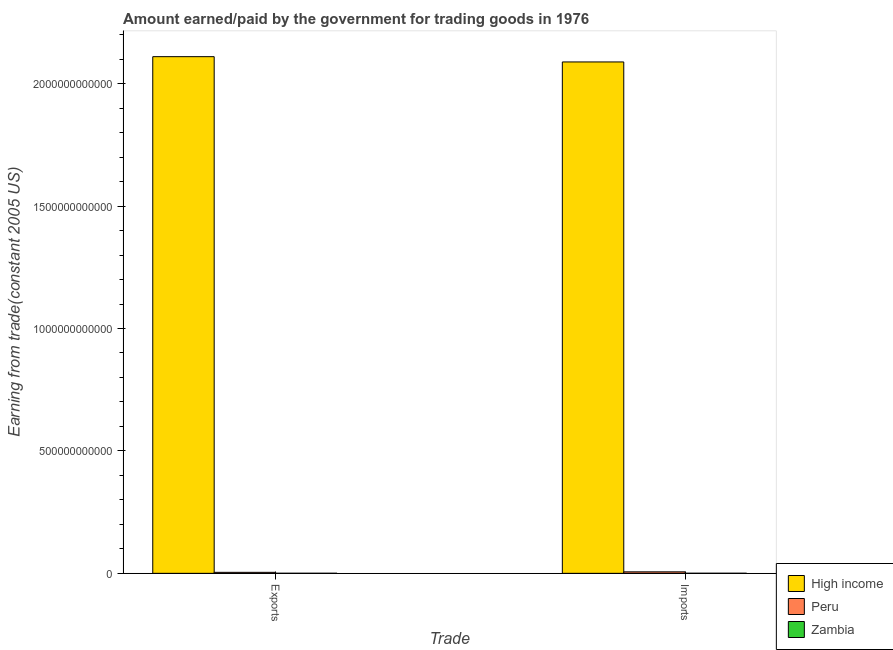How many different coloured bars are there?
Keep it short and to the point. 3. How many groups of bars are there?
Your answer should be compact. 2. How many bars are there on the 1st tick from the right?
Your answer should be compact. 3. What is the label of the 1st group of bars from the left?
Ensure brevity in your answer.  Exports. What is the amount paid for imports in Peru?
Give a very brief answer. 6.07e+09. Across all countries, what is the maximum amount paid for imports?
Provide a short and direct response. 2.09e+12. Across all countries, what is the minimum amount earned from exports?
Give a very brief answer. 3.03e+08. In which country was the amount earned from exports minimum?
Give a very brief answer. Zambia. What is the total amount earned from exports in the graph?
Offer a very short reply. 2.11e+12. What is the difference between the amount paid for imports in High income and that in Zambia?
Give a very brief answer. 2.09e+12. What is the difference between the amount earned from exports in High income and the amount paid for imports in Peru?
Offer a terse response. 2.10e+12. What is the average amount paid for imports per country?
Offer a terse response. 6.98e+11. What is the difference between the amount paid for imports and amount earned from exports in Peru?
Provide a short and direct response. 1.97e+09. What is the ratio of the amount earned from exports in Zambia to that in Peru?
Your answer should be very brief. 0.07. Is the amount earned from exports in Peru less than that in High income?
Keep it short and to the point. Yes. What does the 3rd bar from the right in Imports represents?
Offer a terse response. High income. How many bars are there?
Provide a short and direct response. 6. How many countries are there in the graph?
Make the answer very short. 3. What is the difference between two consecutive major ticks on the Y-axis?
Ensure brevity in your answer.  5.00e+11. Does the graph contain any zero values?
Your response must be concise. No. Does the graph contain grids?
Ensure brevity in your answer.  No. Where does the legend appear in the graph?
Ensure brevity in your answer.  Bottom right. What is the title of the graph?
Your response must be concise. Amount earned/paid by the government for trading goods in 1976. What is the label or title of the X-axis?
Keep it short and to the point. Trade. What is the label or title of the Y-axis?
Make the answer very short. Earning from trade(constant 2005 US). What is the Earning from trade(constant 2005 US) of High income in Exports?
Ensure brevity in your answer.  2.11e+12. What is the Earning from trade(constant 2005 US) in Peru in Exports?
Keep it short and to the point. 4.10e+09. What is the Earning from trade(constant 2005 US) in Zambia in Exports?
Keep it short and to the point. 3.03e+08. What is the Earning from trade(constant 2005 US) of High income in Imports?
Your answer should be compact. 2.09e+12. What is the Earning from trade(constant 2005 US) in Peru in Imports?
Your answer should be compact. 6.07e+09. What is the Earning from trade(constant 2005 US) of Zambia in Imports?
Your answer should be compact. 3.89e+08. Across all Trade, what is the maximum Earning from trade(constant 2005 US) in High income?
Your response must be concise. 2.11e+12. Across all Trade, what is the maximum Earning from trade(constant 2005 US) of Peru?
Make the answer very short. 6.07e+09. Across all Trade, what is the maximum Earning from trade(constant 2005 US) of Zambia?
Offer a very short reply. 3.89e+08. Across all Trade, what is the minimum Earning from trade(constant 2005 US) of High income?
Ensure brevity in your answer.  2.09e+12. Across all Trade, what is the minimum Earning from trade(constant 2005 US) in Peru?
Keep it short and to the point. 4.10e+09. Across all Trade, what is the minimum Earning from trade(constant 2005 US) of Zambia?
Make the answer very short. 3.03e+08. What is the total Earning from trade(constant 2005 US) of High income in the graph?
Offer a terse response. 4.20e+12. What is the total Earning from trade(constant 2005 US) of Peru in the graph?
Provide a short and direct response. 1.02e+1. What is the total Earning from trade(constant 2005 US) of Zambia in the graph?
Provide a short and direct response. 6.92e+08. What is the difference between the Earning from trade(constant 2005 US) of High income in Exports and that in Imports?
Keep it short and to the point. 2.16e+1. What is the difference between the Earning from trade(constant 2005 US) of Peru in Exports and that in Imports?
Your response must be concise. -1.97e+09. What is the difference between the Earning from trade(constant 2005 US) in Zambia in Exports and that in Imports?
Give a very brief answer. -8.56e+07. What is the difference between the Earning from trade(constant 2005 US) in High income in Exports and the Earning from trade(constant 2005 US) in Peru in Imports?
Keep it short and to the point. 2.10e+12. What is the difference between the Earning from trade(constant 2005 US) in High income in Exports and the Earning from trade(constant 2005 US) in Zambia in Imports?
Provide a succinct answer. 2.11e+12. What is the difference between the Earning from trade(constant 2005 US) in Peru in Exports and the Earning from trade(constant 2005 US) in Zambia in Imports?
Your answer should be compact. 3.71e+09. What is the average Earning from trade(constant 2005 US) in High income per Trade?
Offer a very short reply. 2.10e+12. What is the average Earning from trade(constant 2005 US) of Peru per Trade?
Keep it short and to the point. 5.08e+09. What is the average Earning from trade(constant 2005 US) in Zambia per Trade?
Ensure brevity in your answer.  3.46e+08. What is the difference between the Earning from trade(constant 2005 US) in High income and Earning from trade(constant 2005 US) in Peru in Exports?
Give a very brief answer. 2.11e+12. What is the difference between the Earning from trade(constant 2005 US) in High income and Earning from trade(constant 2005 US) in Zambia in Exports?
Offer a very short reply. 2.11e+12. What is the difference between the Earning from trade(constant 2005 US) in Peru and Earning from trade(constant 2005 US) in Zambia in Exports?
Your answer should be compact. 3.79e+09. What is the difference between the Earning from trade(constant 2005 US) in High income and Earning from trade(constant 2005 US) in Peru in Imports?
Provide a short and direct response. 2.08e+12. What is the difference between the Earning from trade(constant 2005 US) of High income and Earning from trade(constant 2005 US) of Zambia in Imports?
Keep it short and to the point. 2.09e+12. What is the difference between the Earning from trade(constant 2005 US) in Peru and Earning from trade(constant 2005 US) in Zambia in Imports?
Give a very brief answer. 5.68e+09. What is the ratio of the Earning from trade(constant 2005 US) of High income in Exports to that in Imports?
Give a very brief answer. 1.01. What is the ratio of the Earning from trade(constant 2005 US) of Peru in Exports to that in Imports?
Ensure brevity in your answer.  0.68. What is the ratio of the Earning from trade(constant 2005 US) in Zambia in Exports to that in Imports?
Provide a succinct answer. 0.78. What is the difference between the highest and the second highest Earning from trade(constant 2005 US) in High income?
Keep it short and to the point. 2.16e+1. What is the difference between the highest and the second highest Earning from trade(constant 2005 US) in Peru?
Ensure brevity in your answer.  1.97e+09. What is the difference between the highest and the second highest Earning from trade(constant 2005 US) in Zambia?
Ensure brevity in your answer.  8.56e+07. What is the difference between the highest and the lowest Earning from trade(constant 2005 US) of High income?
Give a very brief answer. 2.16e+1. What is the difference between the highest and the lowest Earning from trade(constant 2005 US) in Peru?
Make the answer very short. 1.97e+09. What is the difference between the highest and the lowest Earning from trade(constant 2005 US) of Zambia?
Your response must be concise. 8.56e+07. 